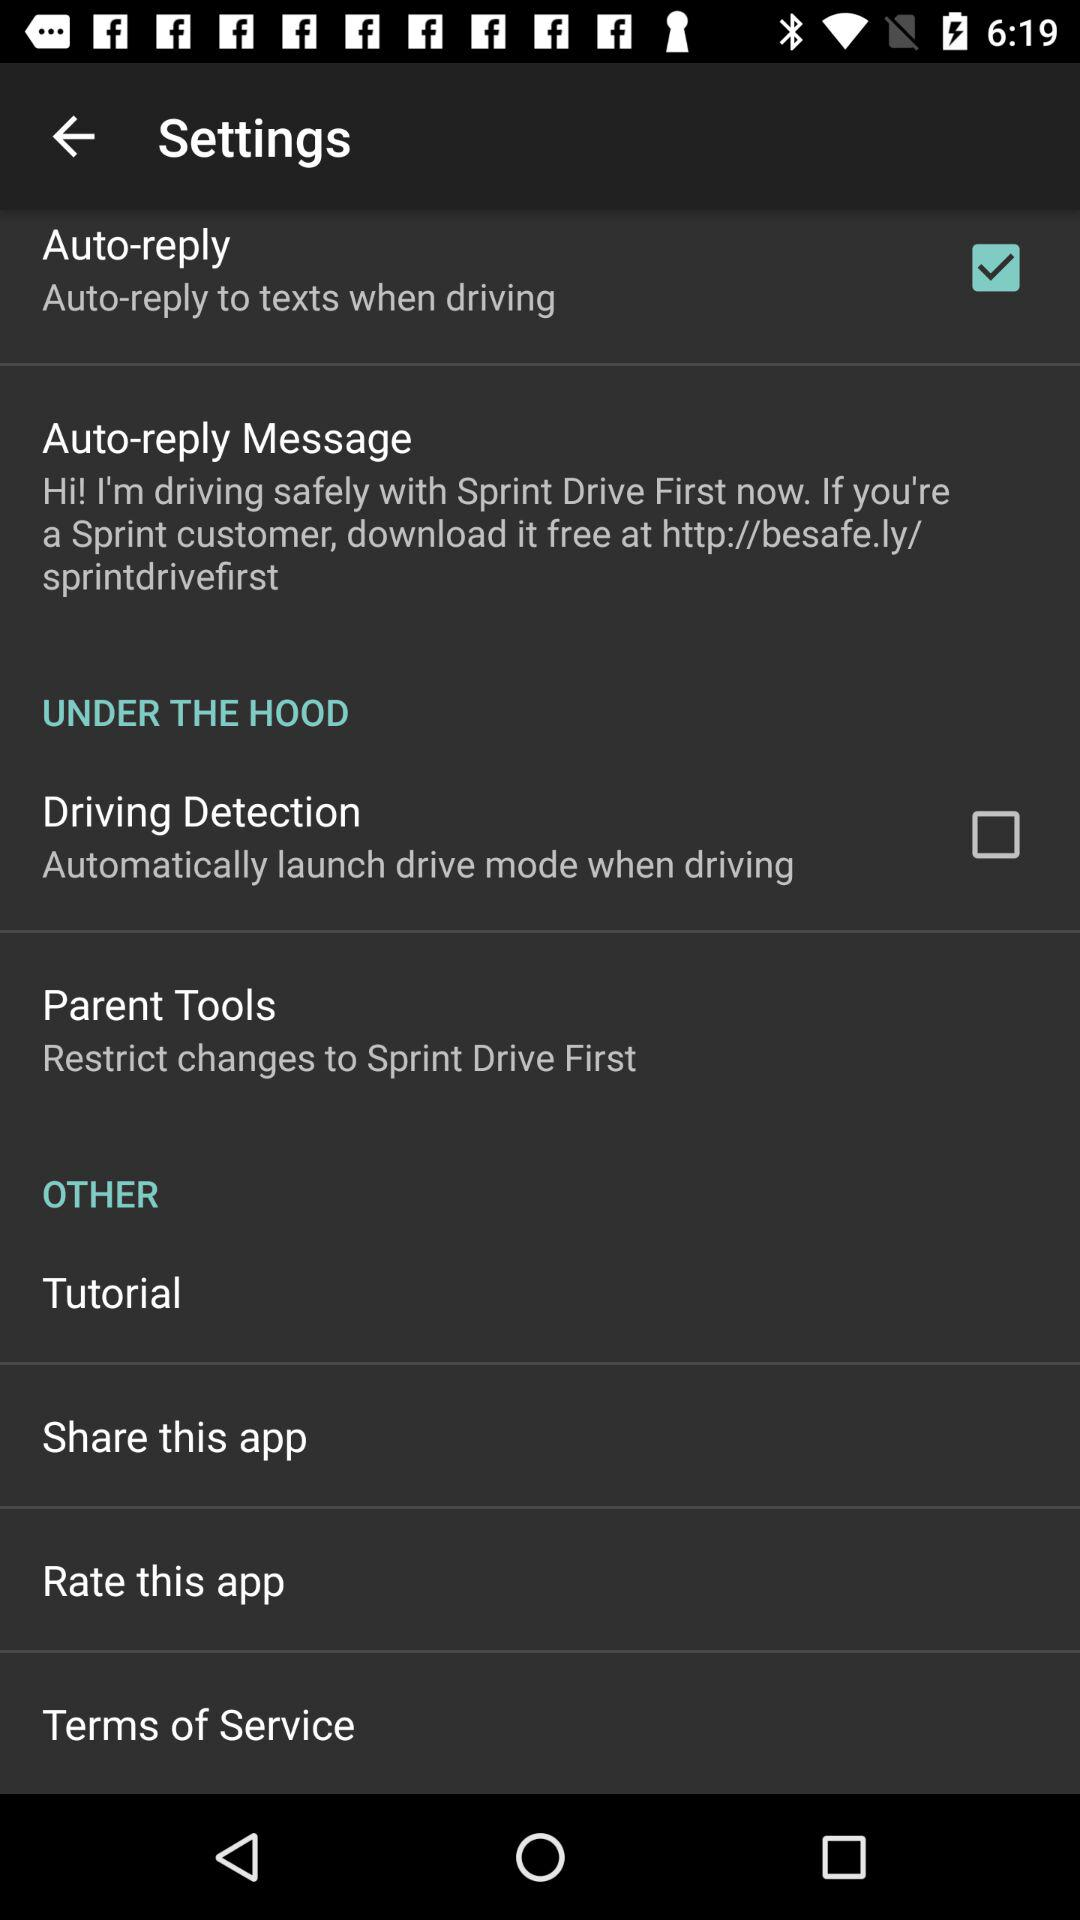What is the status of the "Auto-reply"? The status of the "Auto-reply" is "on". 